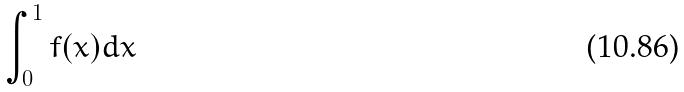Convert formula to latex. <formula><loc_0><loc_0><loc_500><loc_500>\int _ { 0 } ^ { 1 } f ( x ) d x</formula> 